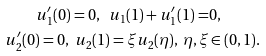<formula> <loc_0><loc_0><loc_500><loc_500>u _ { 1 } ^ { \prime } ( 0 ) = 0 , \ u _ { 1 } ( 1 ) + u _ { 1 } ^ { \prime } ( 1 ) = & 0 , \\ u _ { 2 } ^ { \prime } ( 0 ) = 0 , \ u _ { 2 } ( 1 ) = \xi u _ { 2 } ( \eta ) , \ \eta , \xi & \in ( 0 , 1 ) .</formula> 